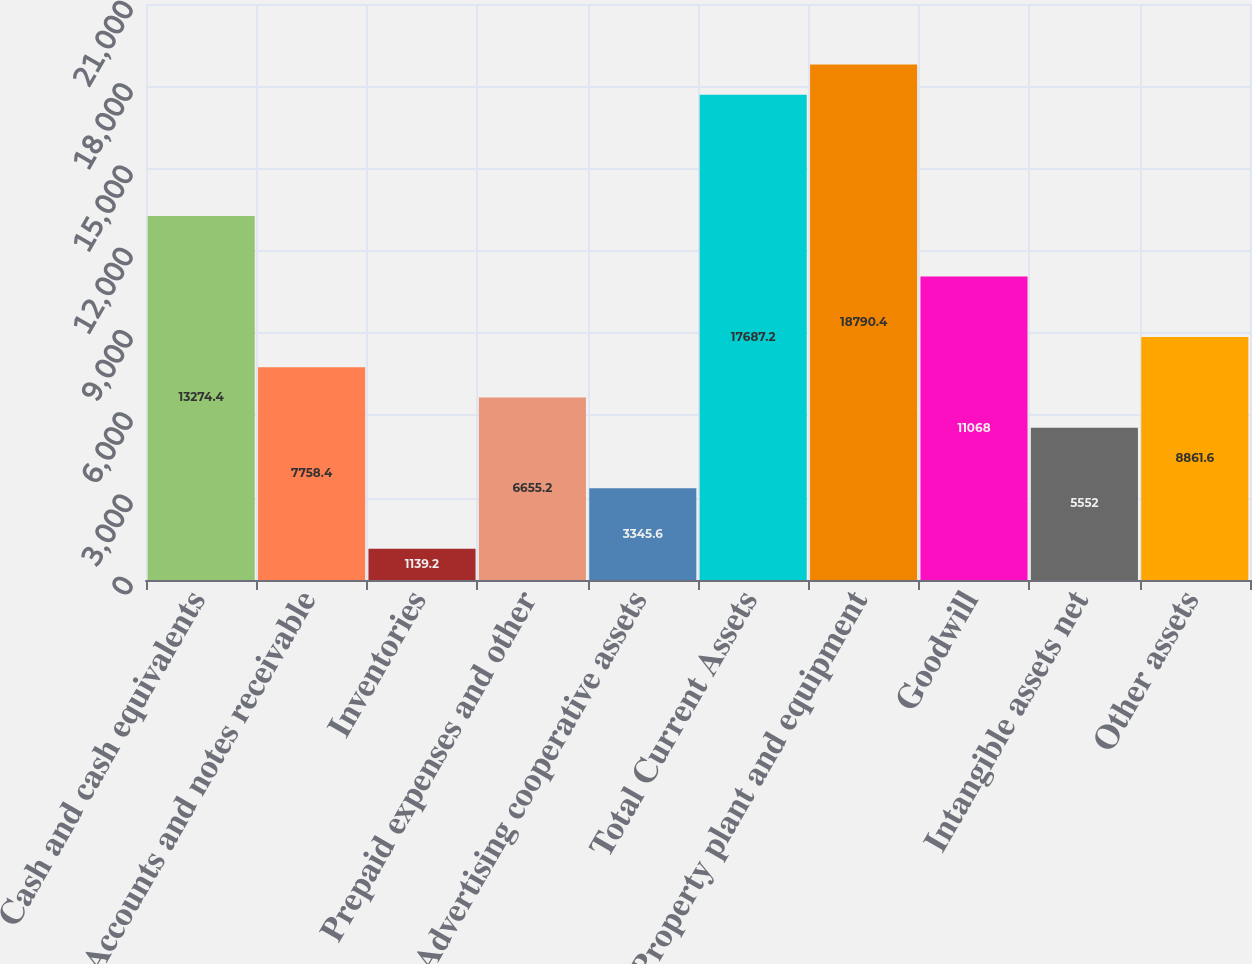Convert chart to OTSL. <chart><loc_0><loc_0><loc_500><loc_500><bar_chart><fcel>Cash and cash equivalents<fcel>Accounts and notes receivable<fcel>Inventories<fcel>Prepaid expenses and other<fcel>Advertising cooperative assets<fcel>Total Current Assets<fcel>Property plant and equipment<fcel>Goodwill<fcel>Intangible assets net<fcel>Other assets<nl><fcel>13274.4<fcel>7758.4<fcel>1139.2<fcel>6655.2<fcel>3345.6<fcel>17687.2<fcel>18790.4<fcel>11068<fcel>5552<fcel>8861.6<nl></chart> 